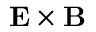Convert formula to latex. <formula><loc_0><loc_0><loc_500><loc_500>E \times B</formula> 